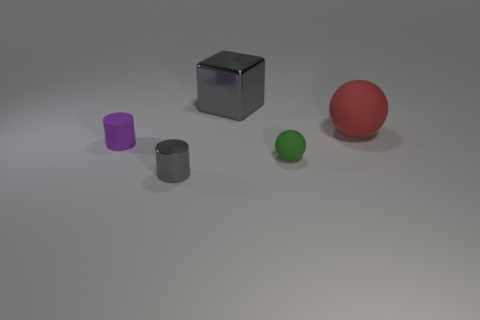There is a metal thing in front of the big block; is its size the same as the ball on the left side of the red rubber sphere?
Offer a terse response. Yes. The green matte object has what shape?
Provide a short and direct response. Sphere. What size is the metallic thing that is the same color as the big metal block?
Make the answer very short. Small. The small cylinder that is made of the same material as the large gray cube is what color?
Keep it short and to the point. Gray. Are the red ball and the gray object on the left side of the large metal cube made of the same material?
Provide a succinct answer. No. The large sphere has what color?
Your answer should be very brief. Red. What is the size of the green ball that is made of the same material as the small purple object?
Give a very brief answer. Small. What number of gray blocks are to the left of the gray object in front of the gray metal object behind the big red object?
Keep it short and to the point. 0. Do the tiny rubber sphere and the thing behind the big red rubber thing have the same color?
Give a very brief answer. No. The big object that is the same color as the metallic cylinder is what shape?
Keep it short and to the point. Cube. 